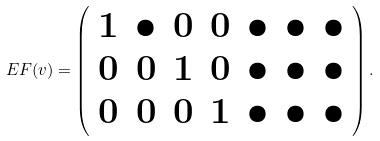<formula> <loc_0><loc_0><loc_500><loc_500>E F ( v ) = \left ( \begin{array} { c c c c c c c } 1 & \bullet & 0 & 0 & \bullet & \bullet & \bullet \\ 0 & 0 & 1 & 0 & \bullet & \bullet & \bullet \\ 0 & 0 & 0 & 1 & \bullet & \bullet & \bullet \end{array} \right ) .</formula> 